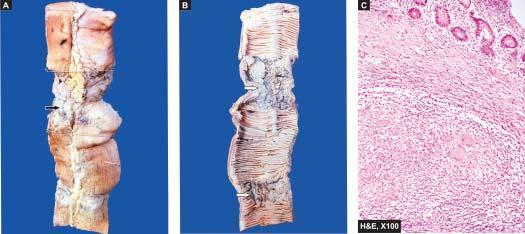s uppurative diseases thickened?
Answer the question using a single word or phrase. No 